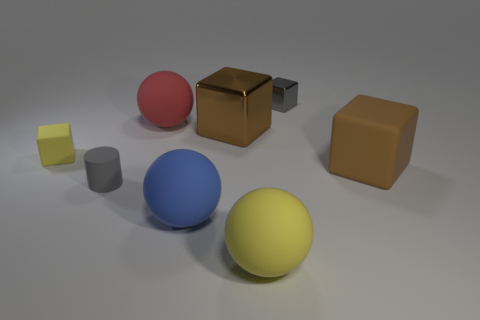How does the lighting in the scene affect the appearance of the objects? The lighting in the scene appears to be soft and diffuse, casting gentle shadows and accentuating the colors and materials of each object. The matte surfaces absorb light, minimizing reflections, while the metallic surfaces reflect the light, highlighting their smooth texture. Can you describe the arrangement of objects in terms of color contrast? Certainly, the arrangement presents a pleasing variety of colors with good contrast. The vivid red, blue, and yellow spheres provide primary color highlights, while the brown and gray cubes offer neutral tones. The contrast is not just in hue, but in saturation as well, creating a visually engaging composition. 